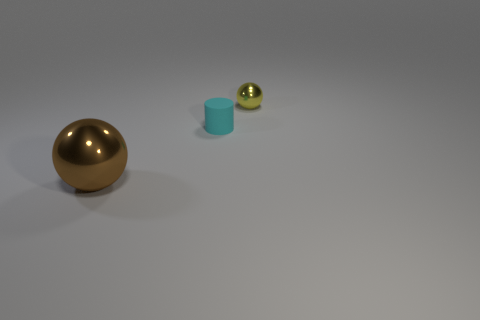Could you tell me the approximate sizes of these objects in relation to each other? Although it's challenging to determine the exact sizes without a reference scale, the brown sphere appears to be the largest object, followed by the blue cylinder which is smaller in diameter but similar in height, and the small sphere has the smallest size of all. 